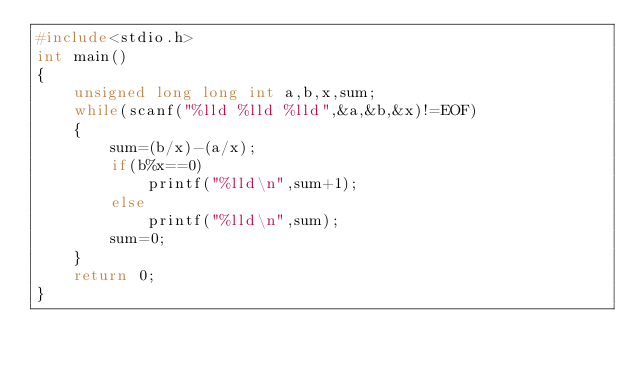<code> <loc_0><loc_0><loc_500><loc_500><_C_>#include<stdio.h>
int main()
{
    unsigned long long int a,b,x,sum;
    while(scanf("%lld %lld %lld",&a,&b,&x)!=EOF)
    {
        sum=(b/x)-(a/x);
        if(b%x==0)
            printf("%lld\n",sum+1);
        else
            printf("%lld\n",sum);
        sum=0;
    }
    return 0;
}
</code> 